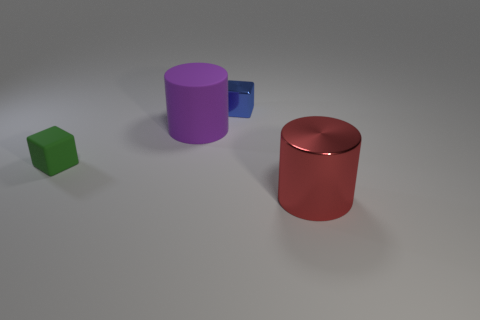Are there any other things of the same shape as the purple matte object?
Provide a short and direct response. Yes. What number of other things are there of the same shape as the tiny rubber thing?
Ensure brevity in your answer.  1. The metal object that is in front of the green object is what color?
Provide a short and direct response. Red. What number of rubber things are tiny green cubes or big purple things?
Offer a terse response. 2. The cube that is in front of the metal thing left of the big metal cylinder is made of what material?
Offer a terse response. Rubber. The small rubber object is what color?
Provide a short and direct response. Green. There is a small cube that is behind the purple matte cylinder; is there a small blue metal thing in front of it?
Your answer should be compact. No. What material is the red cylinder?
Offer a terse response. Metal. Does the block that is right of the rubber block have the same material as the cylinder behind the big red cylinder?
Provide a succinct answer. No. Are there any other things that have the same color as the rubber cylinder?
Offer a terse response. No. 